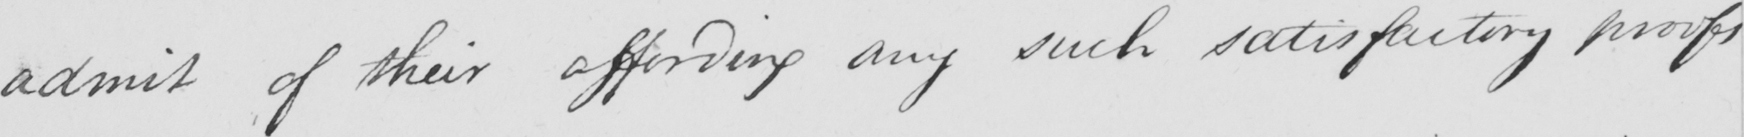Can you read and transcribe this handwriting? admit of their affording any such satisfactory proofs 